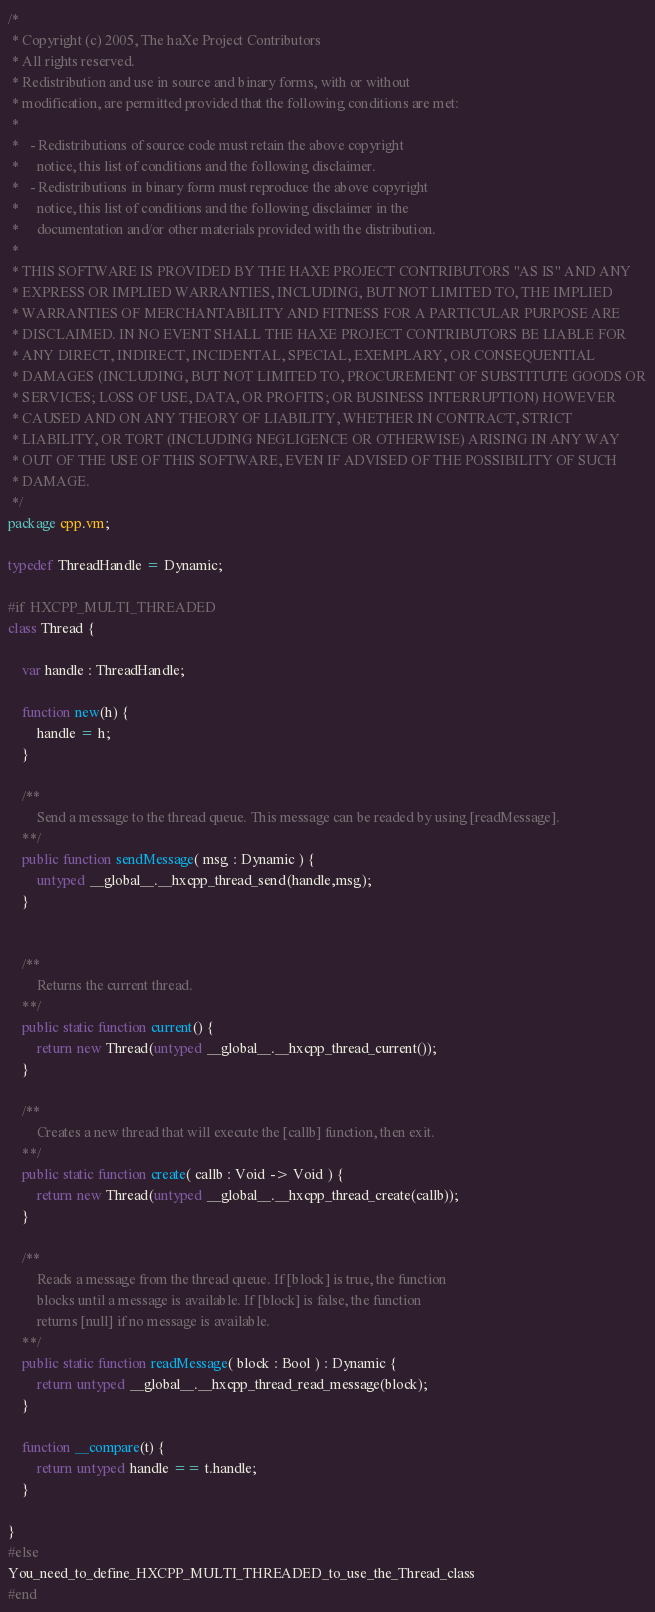Convert code to text. <code><loc_0><loc_0><loc_500><loc_500><_Haxe_>/*
 * Copyright (c) 2005, The haXe Project Contributors
 * All rights reserved.
 * Redistribution and use in source and binary forms, with or without
 * modification, are permitted provided that the following conditions are met:
 *
 *   - Redistributions of source code must retain the above copyright
 *     notice, this list of conditions and the following disclaimer.
 *   - Redistributions in binary form must reproduce the above copyright
 *     notice, this list of conditions and the following disclaimer in the
 *     documentation and/or other materials provided with the distribution.
 *
 * THIS SOFTWARE IS PROVIDED BY THE HAXE PROJECT CONTRIBUTORS "AS IS" AND ANY
 * EXPRESS OR IMPLIED WARRANTIES, INCLUDING, BUT NOT LIMITED TO, THE IMPLIED
 * WARRANTIES OF MERCHANTABILITY AND FITNESS FOR A PARTICULAR PURPOSE ARE
 * DISCLAIMED. IN NO EVENT SHALL THE HAXE PROJECT CONTRIBUTORS BE LIABLE FOR
 * ANY DIRECT, INDIRECT, INCIDENTAL, SPECIAL, EXEMPLARY, OR CONSEQUENTIAL
 * DAMAGES (INCLUDING, BUT NOT LIMITED TO, PROCUREMENT OF SUBSTITUTE GOODS OR
 * SERVICES; LOSS OF USE, DATA, OR PROFITS; OR BUSINESS INTERRUPTION) HOWEVER
 * CAUSED AND ON ANY THEORY OF LIABILITY, WHETHER IN CONTRACT, STRICT
 * LIABILITY, OR TORT (INCLUDING NEGLIGENCE OR OTHERWISE) ARISING IN ANY WAY
 * OUT OF THE USE OF THIS SOFTWARE, EVEN IF ADVISED OF THE POSSIBILITY OF SUCH
 * DAMAGE.
 */
package cpp.vm;

typedef ThreadHandle = Dynamic;

#if HXCPP_MULTI_THREADED
class Thread {

	var handle : ThreadHandle;

	function new(h) {
		handle = h;
	}

	/**
		Send a message to the thread queue. This message can be readed by using [readMessage].
	**/
	public function sendMessage( msg : Dynamic ) {
		untyped __global__.__hxcpp_thread_send(handle,msg);
	}


	/**
		Returns the current thread.
	**/
	public static function current() {
		return new Thread(untyped __global__.__hxcpp_thread_current());
	}

	/**
		Creates a new thread that will execute the [callb] function, then exit.
	**/
	public static function create( callb : Void -> Void ) {
		return new Thread(untyped __global__.__hxcpp_thread_create(callb));
	}

	/**
		Reads a message from the thread queue. If [block] is true, the function
		blocks until a message is available. If [block] is false, the function
		returns [null] if no message is available.
	**/
	public static function readMessage( block : Bool ) : Dynamic {
		return untyped __global__.__hxcpp_thread_read_message(block);
	}

	function __compare(t) {
		return untyped handle == t.handle;
	}

}
#else
You_need_to_define_HXCPP_MULTI_THREADED_to_use_the_Thread_class
#end
</code> 